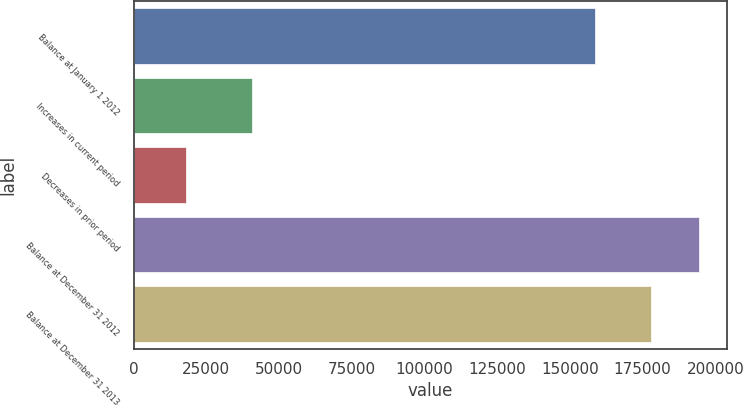Convert chart. <chart><loc_0><loc_0><loc_500><loc_500><bar_chart><fcel>Balance at January 1 2012<fcel>Increases in current period<fcel>Decreases in prior period<fcel>Balance at December 31 2012<fcel>Balance at December 31 2013<nl><fcel>158578<fcel>40620<fcel>18205<fcel>194226<fcel>177947<nl></chart> 